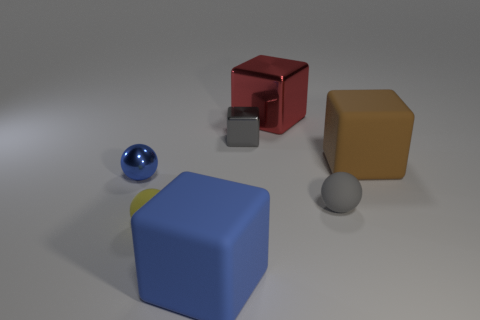Add 2 large brown matte objects. How many objects exist? 9 Subtract all spheres. How many objects are left? 4 Subtract 0 green blocks. How many objects are left? 7 Subtract all brown metallic balls. Subtract all small gray things. How many objects are left? 5 Add 1 blue things. How many blue things are left? 3 Add 5 gray spheres. How many gray spheres exist? 6 